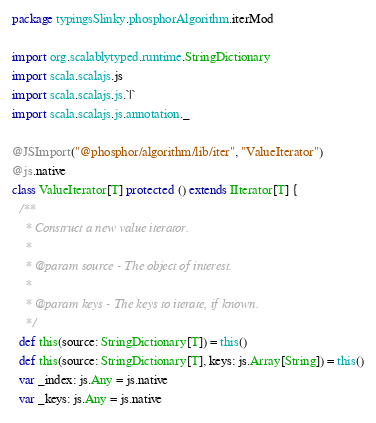Convert code to text. <code><loc_0><loc_0><loc_500><loc_500><_Scala_>package typingsSlinky.phosphorAlgorithm.iterMod

import org.scalablytyped.runtime.StringDictionary
import scala.scalajs.js
import scala.scalajs.js.`|`
import scala.scalajs.js.annotation._

@JSImport("@phosphor/algorithm/lib/iter", "ValueIterator")
@js.native
class ValueIterator[T] protected () extends IIterator[T] {
  /**
    * Construct a new value iterator.
    *
    * @param source - The object of interest.
    *
    * @param keys - The keys to iterate, if known.
    */
  def this(source: StringDictionary[T]) = this()
  def this(source: StringDictionary[T], keys: js.Array[String]) = this()
  var _index: js.Any = js.native
  var _keys: js.Any = js.native</code> 